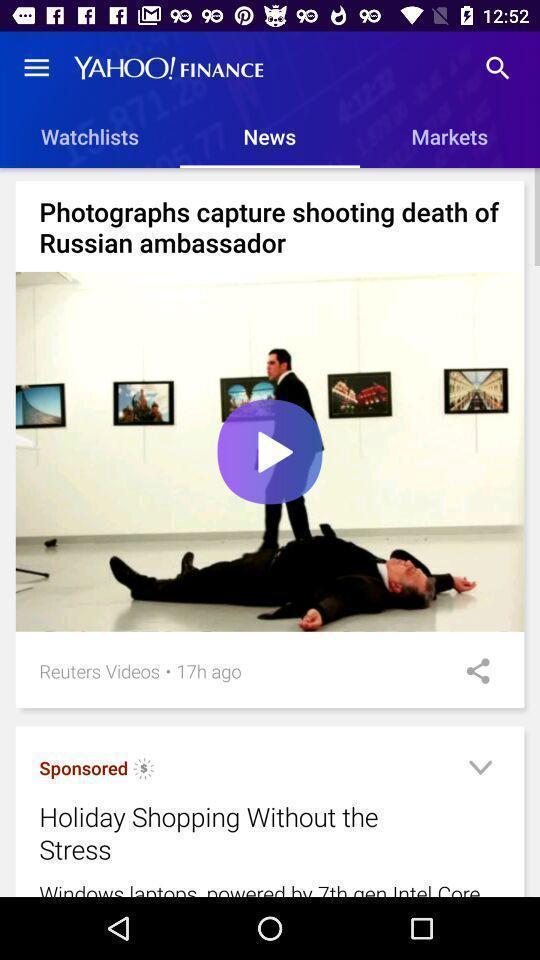What is the overall content of this screenshot? Various article displayed of a financial applications. 